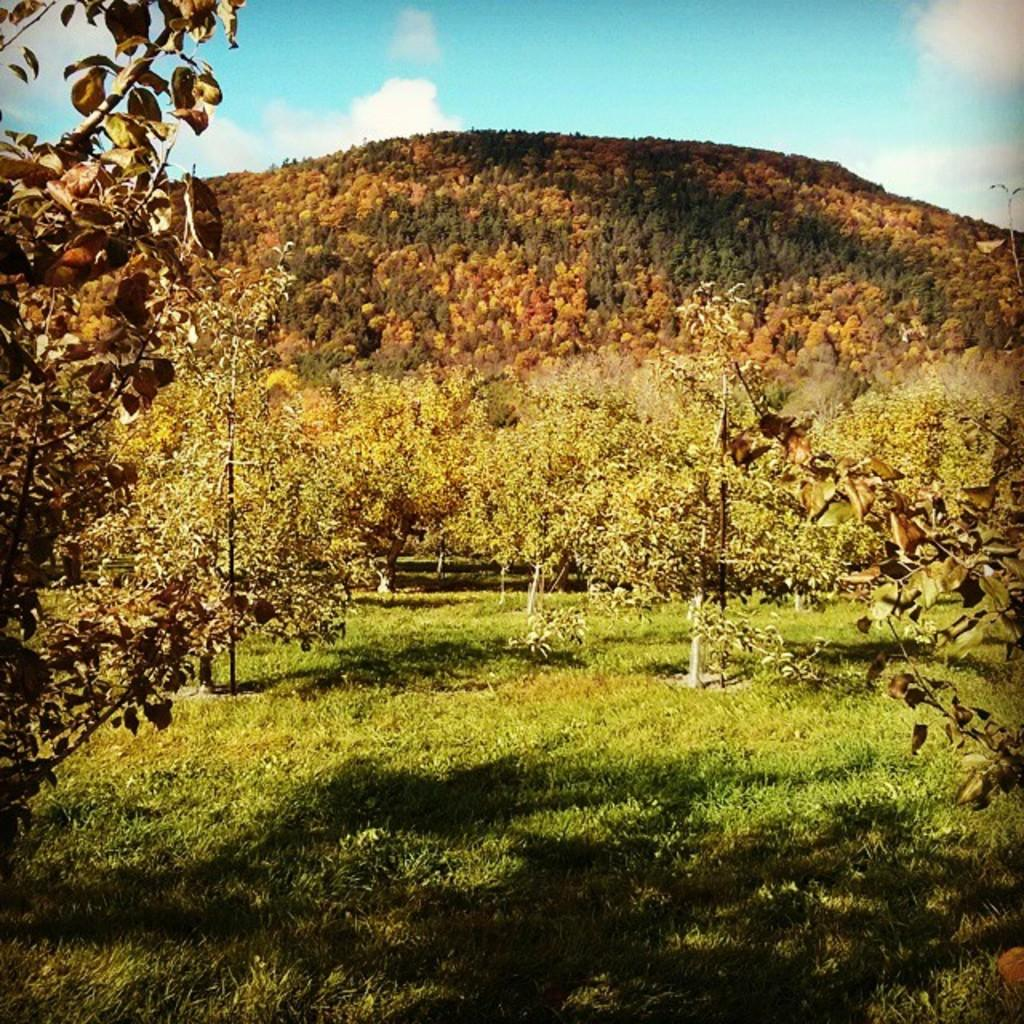What type of vegetation can be seen in the image? There are trees, grass, and plants in the image. What type of terrain is visible in the image? There are hills in the image. What is visible in the background of the image? The sky is visible in the image, along with clouds. How many boats can be seen in the image? There are no boats present in the image. What type of needle is used to create the cobweb in the image? There is no cobweb present in the image, and therefore no needles are involved. 